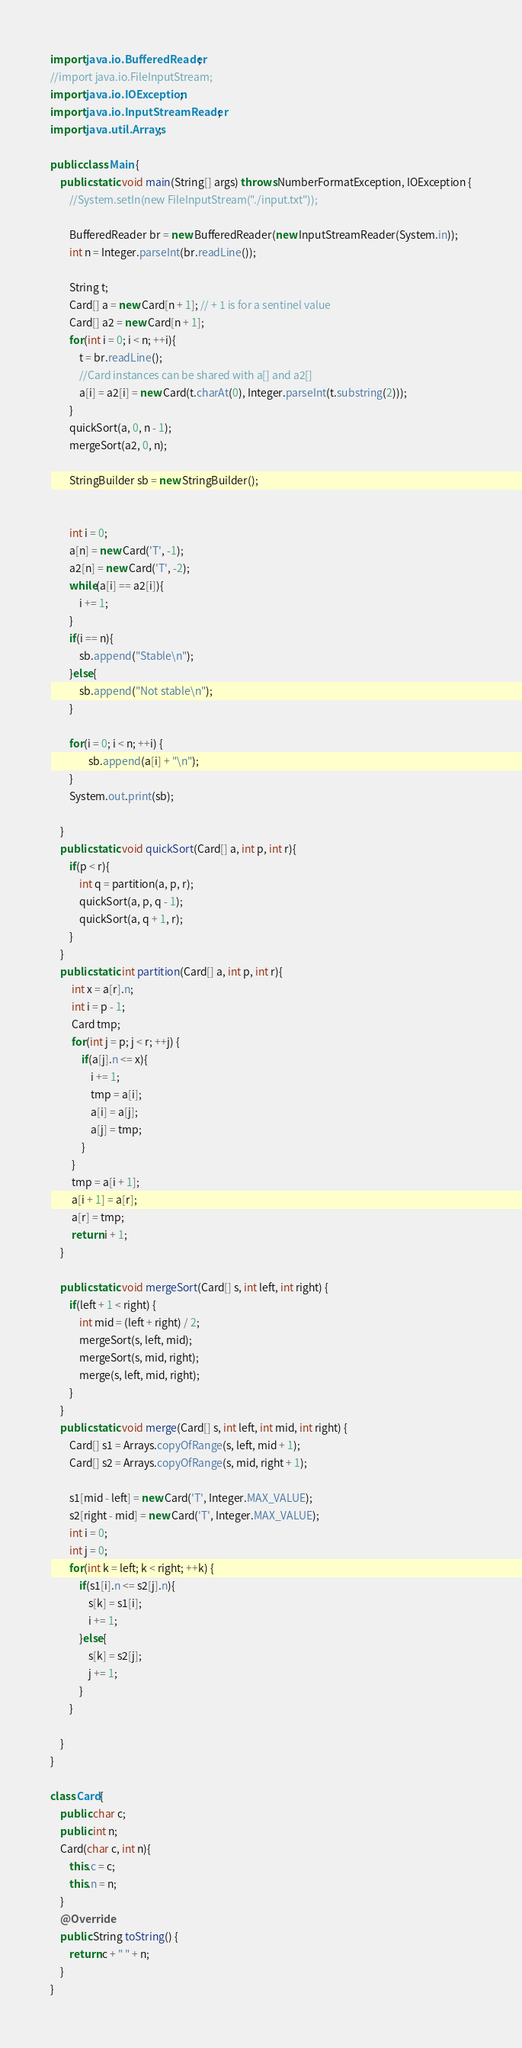Convert code to text. <code><loc_0><loc_0><loc_500><loc_500><_Java_>import java.io.BufferedReader;
//import java.io.FileInputStream;
import java.io.IOException;
import java.io.InputStreamReader;
import java.util.Arrays;

public class Main {
	public static void main(String[] args) throws NumberFormatException, IOException {
		//System.setIn(new FileInputStream("./input.txt"));
		
		BufferedReader br = new BufferedReader(new InputStreamReader(System.in));
		int n = Integer.parseInt(br.readLine());

		String t;
		Card[] a = new Card[n + 1]; // + 1 is for a sentinel value 
		Card[] a2 = new Card[n + 1];
		for(int i = 0; i < n; ++i){
			t = br.readLine();
			//Card instances can be shared with a[] and a2[]
			a[i] = a2[i] = new Card(t.charAt(0), Integer.parseInt(t.substring(2)));
		}
		quickSort(a, 0, n - 1);
		mergeSort(a2, 0, n);
		
		StringBuilder sb = new StringBuilder();
		
		
		int i = 0;
		a[n] = new Card('T', -1);
		a2[n] = new Card('T', -2);
		while(a[i] == a2[i]){
			i += 1;
		}
		if(i == n){
			sb.append("Stable\n");
		}else{
			sb.append("Not stable\n");
		}
		
		for(i = 0; i < n; ++i) {
				sb.append(a[i] + "\n");
		}
		System.out.print(sb);
		
	}
	public static void quickSort(Card[] a, int p, int r){
		if(p < r){
			int q = partition(a, p, r);
			quickSort(a, p, q - 1);
			quickSort(a, q + 1, r);
		}
	}
	public static int partition(Card[] a, int p, int r){
		 int x = a[r].n;
		 int i = p - 1;
		 Card tmp;
		 for(int j = p; j < r; ++j) {
			 if(a[j].n <= x){
				 i += 1;
				 tmp = a[i];
				 a[i] = a[j];
				 a[j] = tmp;
			 }
		 }
		 tmp = a[i + 1];
		 a[i + 1] = a[r];
		 a[r] = tmp;
		 return i + 1;
	}

	public static void mergeSort(Card[] s, int left, int right) {
		if(left + 1 < right) {
			int mid = (left + right) / 2;
			mergeSort(s, left, mid);
			mergeSort(s, mid, right);
			merge(s, left, mid, right);
		}
	}
	public static void merge(Card[] s, int left, int mid, int right) {
		Card[] s1 = Arrays.copyOfRange(s, left, mid + 1);
		Card[] s2 = Arrays.copyOfRange(s, mid, right + 1);
		
		s1[mid - left] = new Card('T', Integer.MAX_VALUE);
		s2[right - mid] = new Card('T', Integer.MAX_VALUE);
		int i = 0;
		int j = 0;
		for(int k = left; k < right; ++k) {
			if(s1[i].n <= s2[j].n){
				s[k] = s1[i];
				i += 1;
			}else{
				s[k] = s2[j];
				j += 1;
			}
		}
		
	}
}

class Card{
	public char c;
	public int n;
	Card(char c, int n){
		this.c = c;
		this.n = n;
	}
	@Override
	public String toString() {
		return c + " " + n;
	}
}</code> 